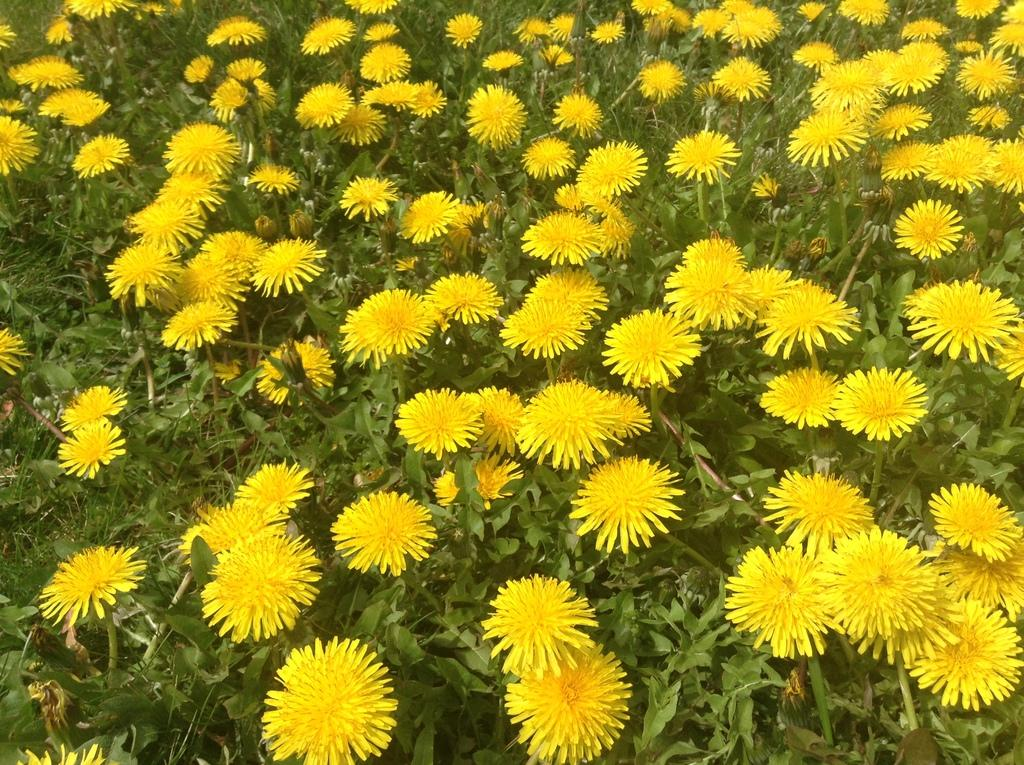What type of living organisms are present in the image? The image contains plants. What specific features can be observed on the plants? The plants have flowers. What color are the flowers? The flowers are in yellow color. How many fingers can be seen holding the yellow flowers in the image? There are no fingers or hands visible in the image; it only shows plants with yellow flowers. 